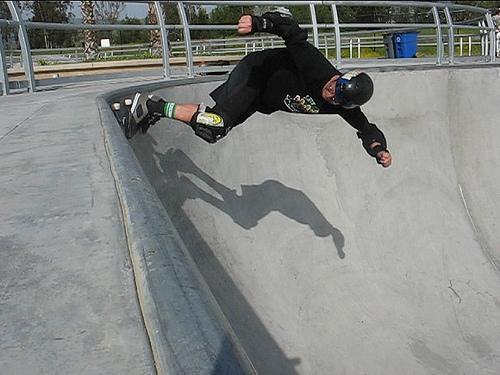How many people are wearing an orange tee shirt?
Give a very brief answer. 0. 